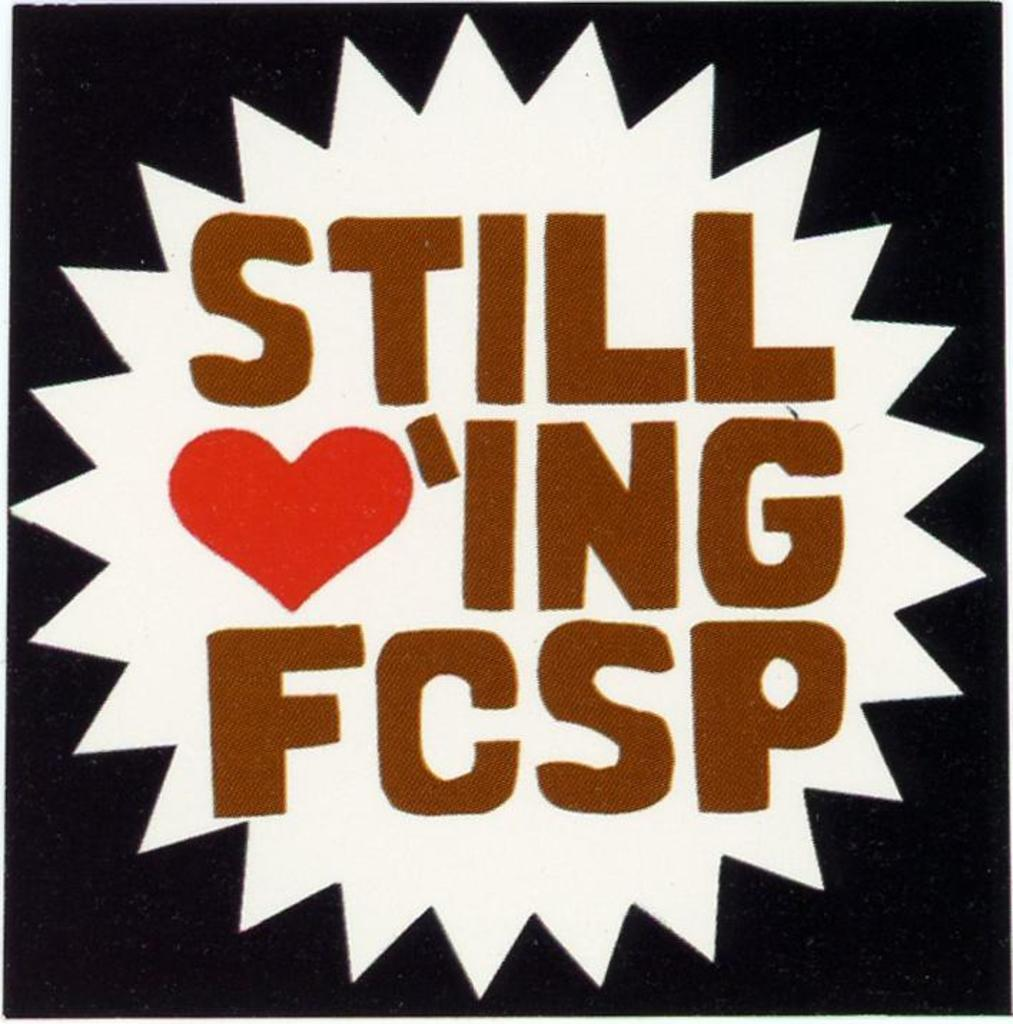<image>
Provide a brief description of the given image. A poster that says Still Lov'ing FCSP, with the letters LOV replaced with a red heart symbol. 